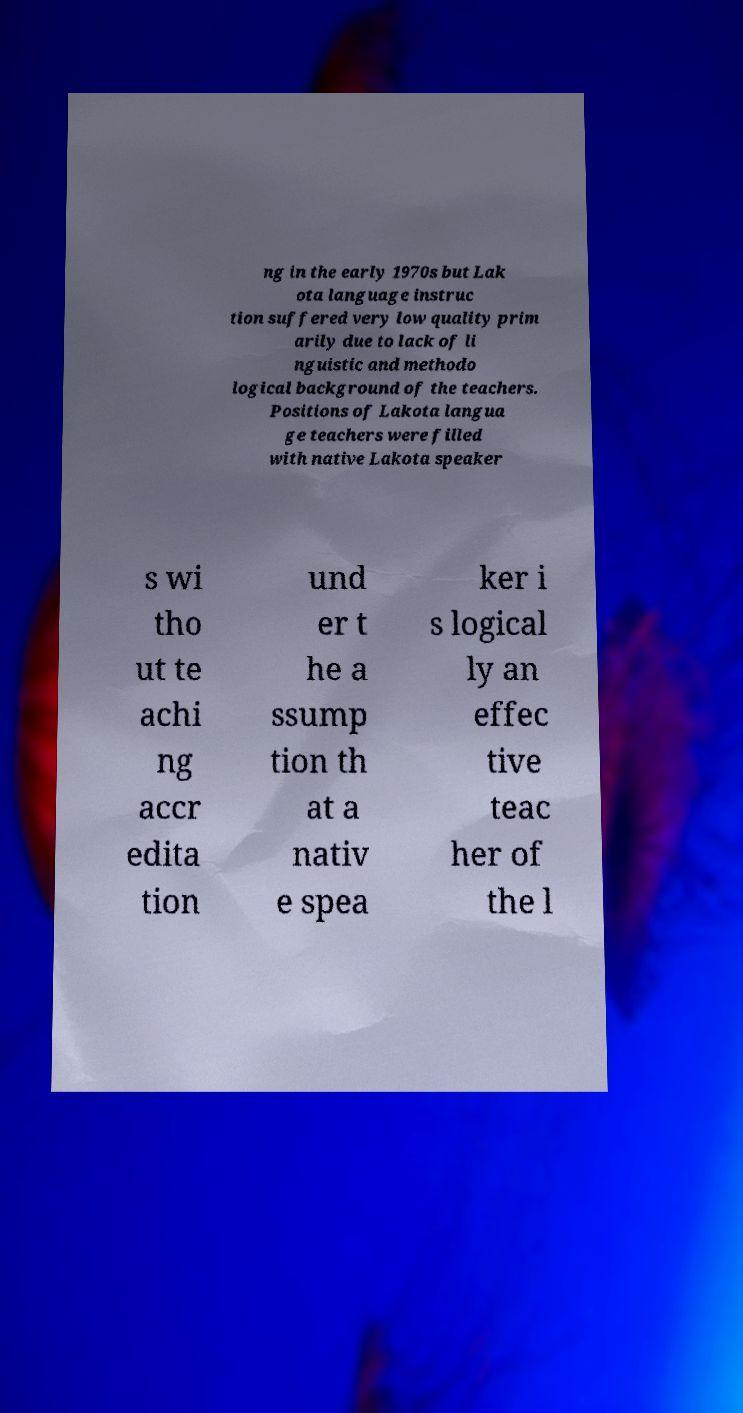I need the written content from this picture converted into text. Can you do that? ng in the early 1970s but Lak ota language instruc tion suffered very low quality prim arily due to lack of li nguistic and methodo logical background of the teachers. Positions of Lakota langua ge teachers were filled with native Lakota speaker s wi tho ut te achi ng accr edita tion und er t he a ssump tion th at a nativ e spea ker i s logical ly an effec tive teac her of the l 